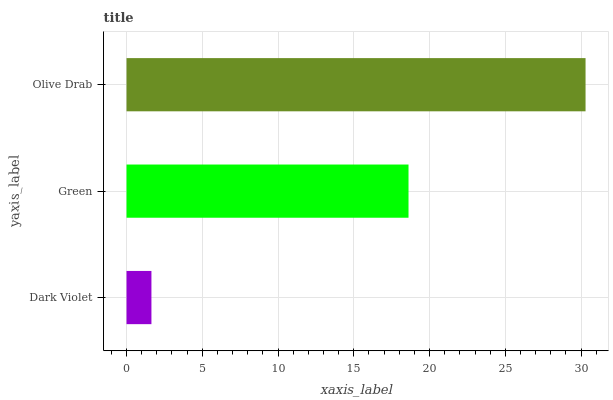Is Dark Violet the minimum?
Answer yes or no. Yes. Is Olive Drab the maximum?
Answer yes or no. Yes. Is Green the minimum?
Answer yes or no. No. Is Green the maximum?
Answer yes or no. No. Is Green greater than Dark Violet?
Answer yes or no. Yes. Is Dark Violet less than Green?
Answer yes or no. Yes. Is Dark Violet greater than Green?
Answer yes or no. No. Is Green less than Dark Violet?
Answer yes or no. No. Is Green the high median?
Answer yes or no. Yes. Is Green the low median?
Answer yes or no. Yes. Is Dark Violet the high median?
Answer yes or no. No. Is Dark Violet the low median?
Answer yes or no. No. 